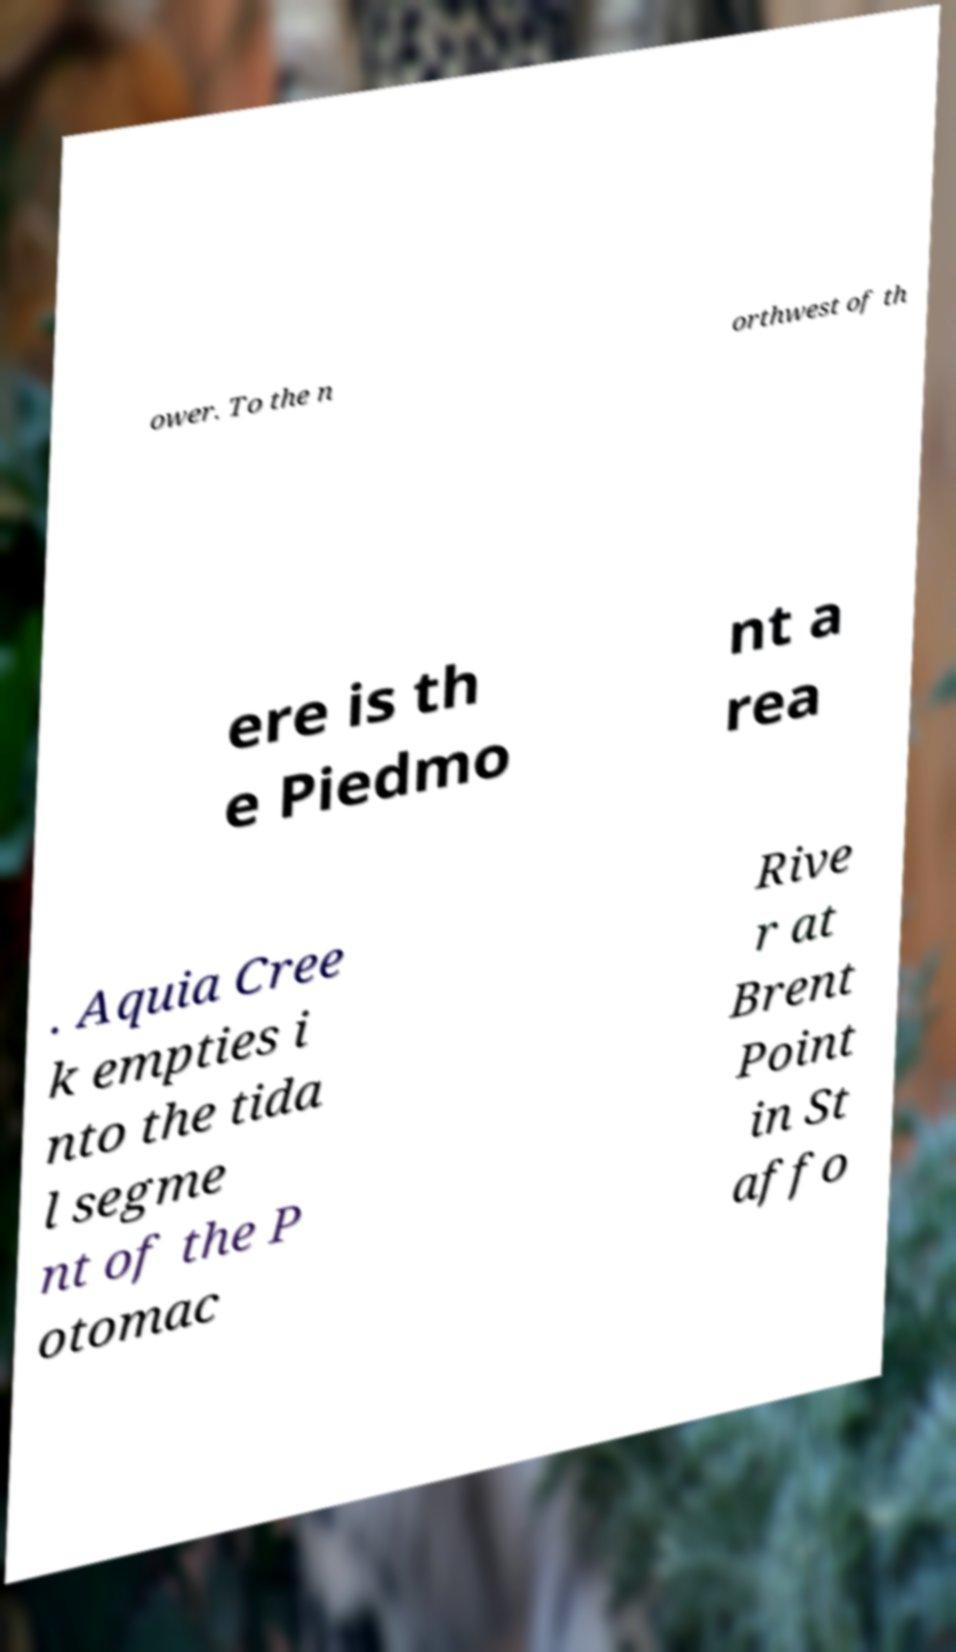Can you accurately transcribe the text from the provided image for me? ower. To the n orthwest of th ere is th e Piedmo nt a rea . Aquia Cree k empties i nto the tida l segme nt of the P otomac Rive r at Brent Point in St affo 